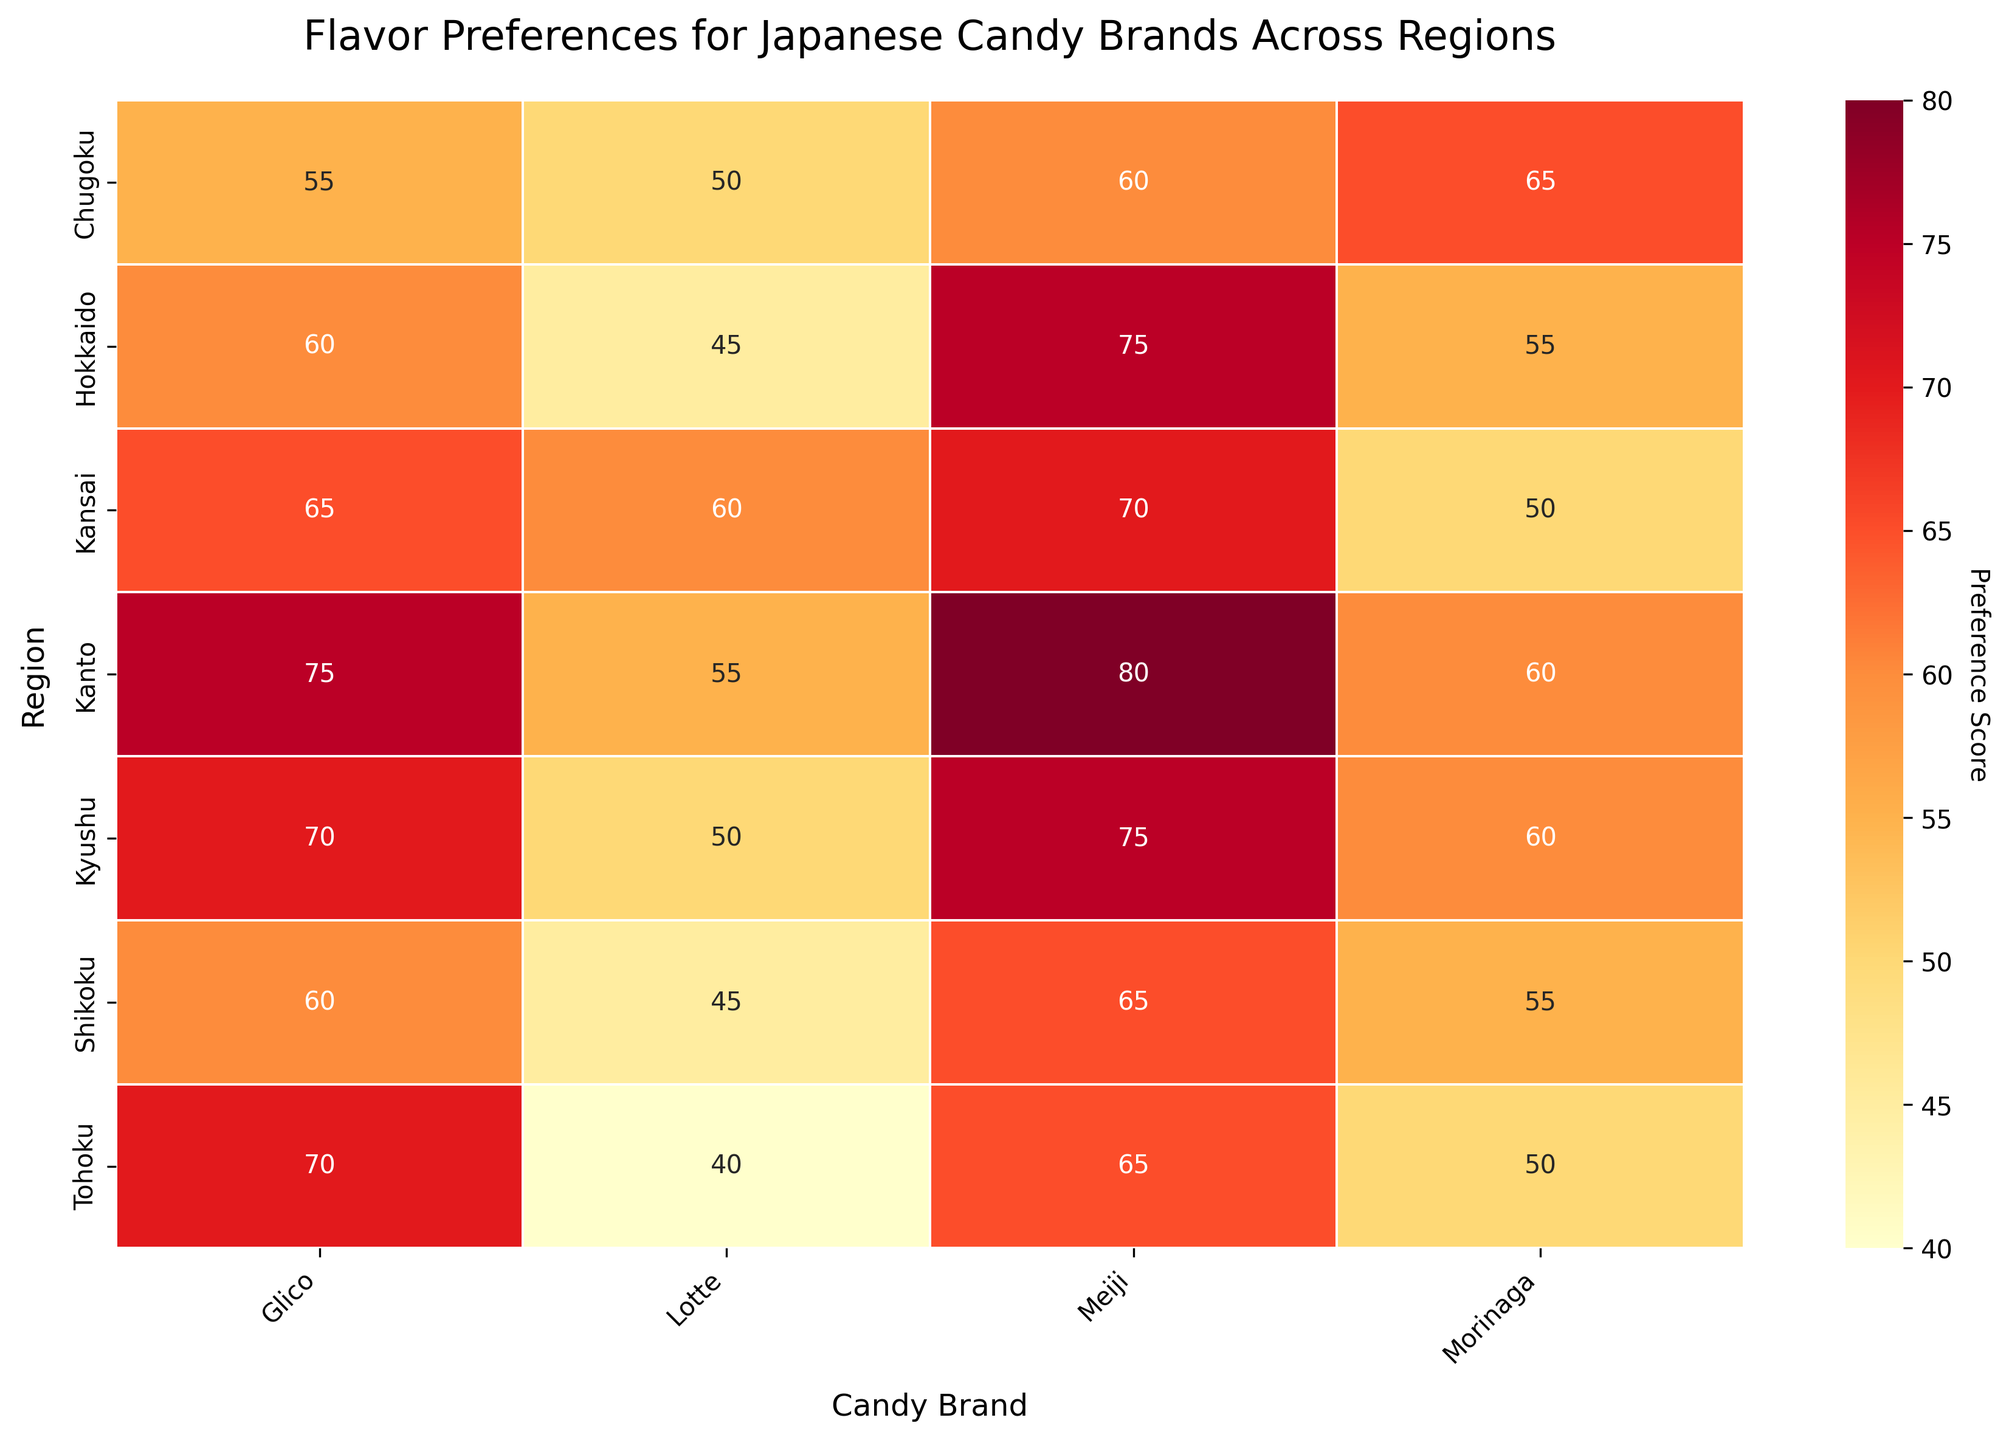What is the highest preference score in the heatmap? Look for the cell with the highest number in the heatmap. The highest value is 80 for Meiji Chocolate in the Kanto region.
Answer: 80 What is the title of the heatmap? The title is located at the top of the heatmap. It reads "Flavor Preferences for Japanese Candy Brands Across Regions."
Answer: Flavor Preferences for Japanese Candy Brands Across Regions Which region has the lowest preference score for Lotte's Mango flavor? Check the values under the Lotte’s Mango column and identify the smallest number. The lowest value is 40 in the Tohoku region.
Answer: Tohoku What's the average preference score for Meiji Chocolate across all regions? Extract the values for Meiji Chocolate from each region (75, 65, 80, 70, 60, 65, 75). Sum these values: 75 + 65 + 80 + 70 + 60 + 65 + 75 = 490. There are 7 values, so calculate the average: 490 / 7 ≈ 70
Answer: 70 Which candy brand has the highest preference score in Chugoku? Look at the row for Chugoku and find the highest value. The highest value in Chugoku is 65 for Morinaga Green Tea.
Answer: Morinaga Which region prefers Glico's Strawberry flavor the most? Check the values under the Glico’s Strawberry column and identify the highest number. The highest value is 75 for the Kanto region.
Answer: Kanto What's the difference in preference scores for Morinaga's Green Tea between Kanto and Kansai? Find the values for Morinaga's Green Tea in Kanto (60) and Kansai (50). Calculate the difference: 60 - 50 = 10
Answer: 10 Which candy brand has the most even distribution of preference scores across all regions? Compare the spread and consistency of the scores for each candy brand across the regions. Meiji Chocolate has scores close to each other (75, 65, 80, 70, 60, 65, 75).
Answer: Meiji What color represents higher preference scores on the heatmap? Higher preference scores are indicated by more intense colors in the YlOrRd (Yellow to Red) colormap. Therefore, darker red colors represent higher scores.
Answer: Dark Red In which regions does Morinaga's Green Tea have the same preference score? Examine the values for Morinaga’s Green Tea across all regions. The score is 60 in both Kanto and Kyushu.
Answer: Kanto and Kyushu 